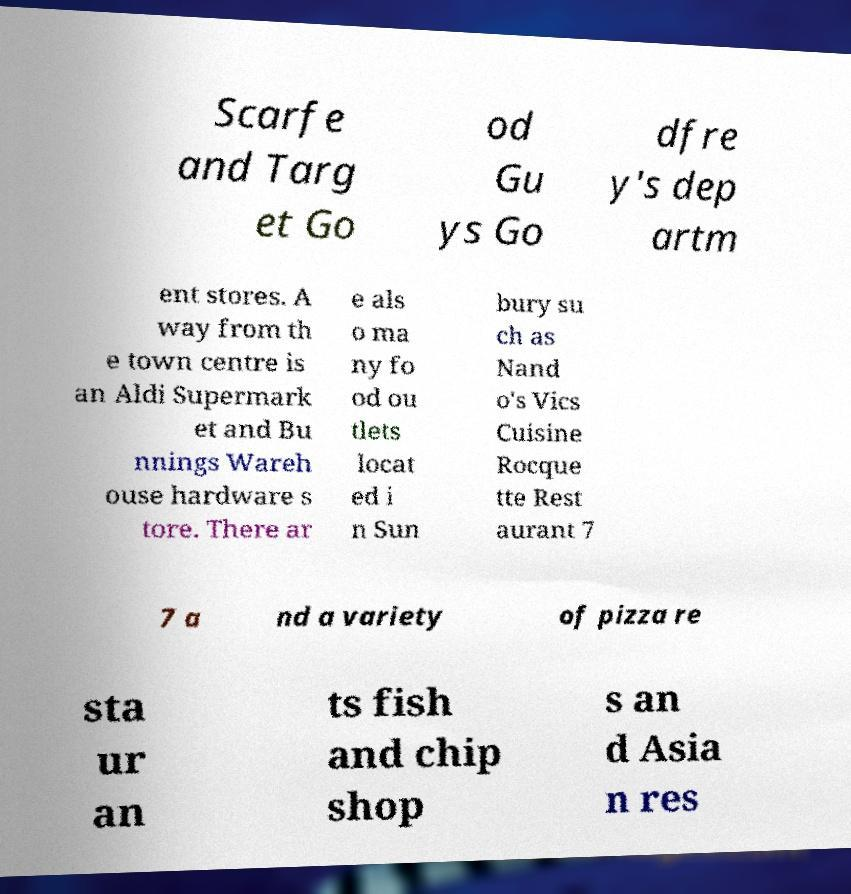I need the written content from this picture converted into text. Can you do that? Scarfe and Targ et Go od Gu ys Go dfre y's dep artm ent stores. A way from th e town centre is an Aldi Supermark et and Bu nnings Wareh ouse hardware s tore. There ar e als o ma ny fo od ou tlets locat ed i n Sun bury su ch as Nand o's Vics Cuisine Rocque tte Rest aurant 7 7 a nd a variety of pizza re sta ur an ts fish and chip shop s an d Asia n res 